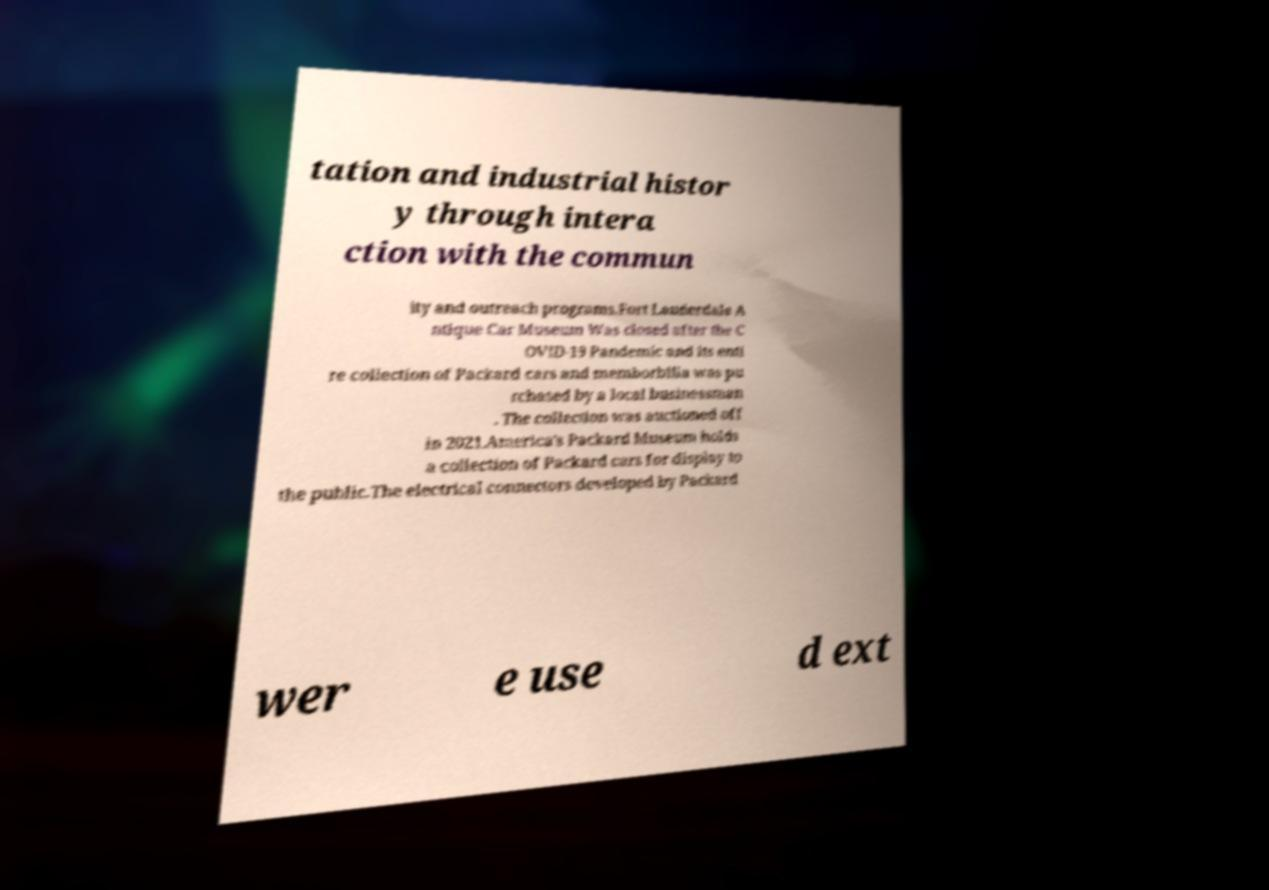There's text embedded in this image that I need extracted. Can you transcribe it verbatim? tation and industrial histor y through intera ction with the commun ity and outreach programs.Fort Lauderdale A ntique Car Museum Was closed after the C OVID-19 Pandemic and its enti re collection of Packard cars and memborbilla was pu rchased by a local businessman . The collection was auctioned off in 2021.America's Packard Museum holds a collection of Packard cars for display to the public.The electrical connectors developed by Packard wer e use d ext 